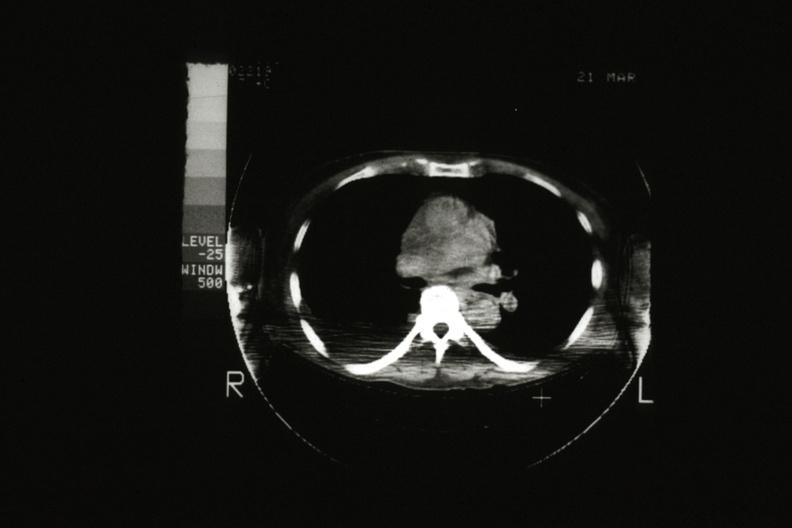s stillborn macerated present?
Answer the question using a single word or phrase. No 